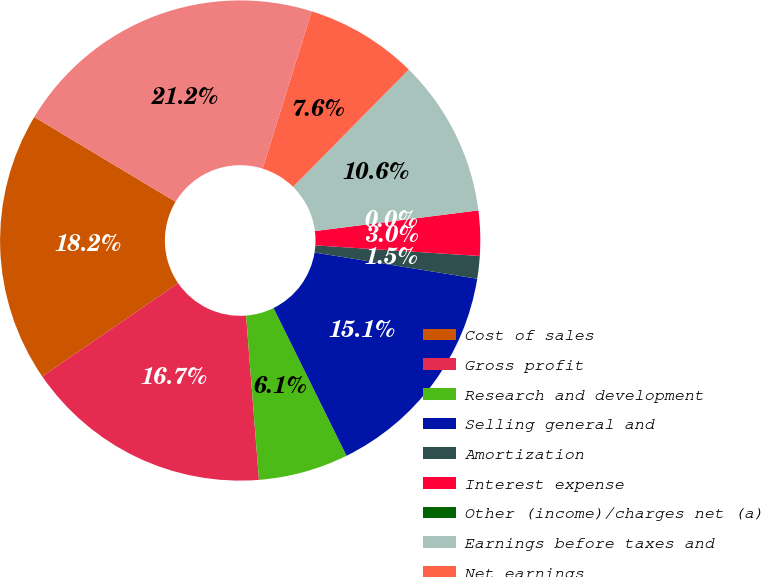<chart> <loc_0><loc_0><loc_500><loc_500><pie_chart><fcel>Cost of sales<fcel>Gross profit<fcel>Research and development<fcel>Selling general and<fcel>Amortization<fcel>Interest expense<fcel>Other (income)/charges net (a)<fcel>Earnings before taxes and<fcel>Net earnings<fcel>Weighted average number of<nl><fcel>18.18%<fcel>16.67%<fcel>6.06%<fcel>15.15%<fcel>1.52%<fcel>3.03%<fcel>0.0%<fcel>10.61%<fcel>7.58%<fcel>21.21%<nl></chart> 